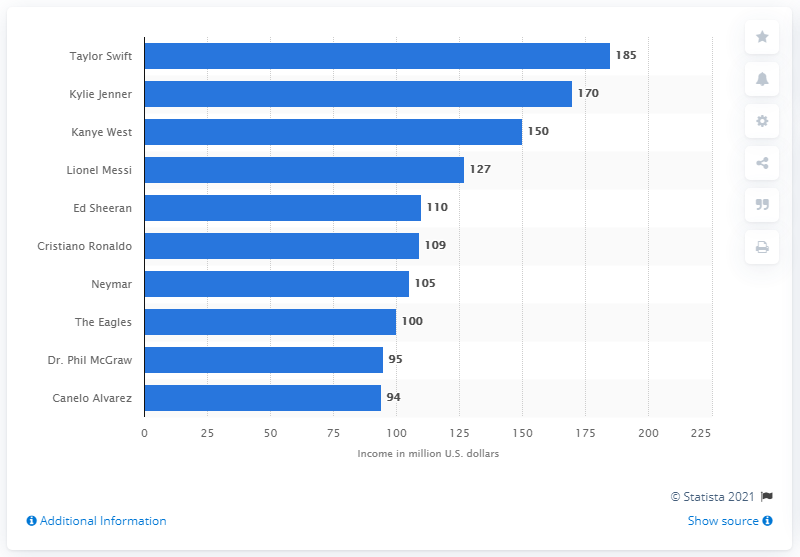Identify some key points in this picture. Taylor Swift's annual income between June 2018 and June 2019 was approximately $185 million. Kanye West earned a total of 185 million dollars between June 2018 and June 2019. Ed Sheeran's annual earnings were estimated to be 110 million dollars. 